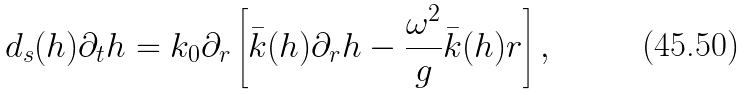<formula> <loc_0><loc_0><loc_500><loc_500>d _ { s } ( h ) \partial _ { t } h = k _ { 0 } \partial _ { r } \left [ \bar { k } ( h ) \partial _ { r } h - \frac { \omega ^ { 2 } } { g } \bar { k } ( h ) r \right ] ,</formula> 